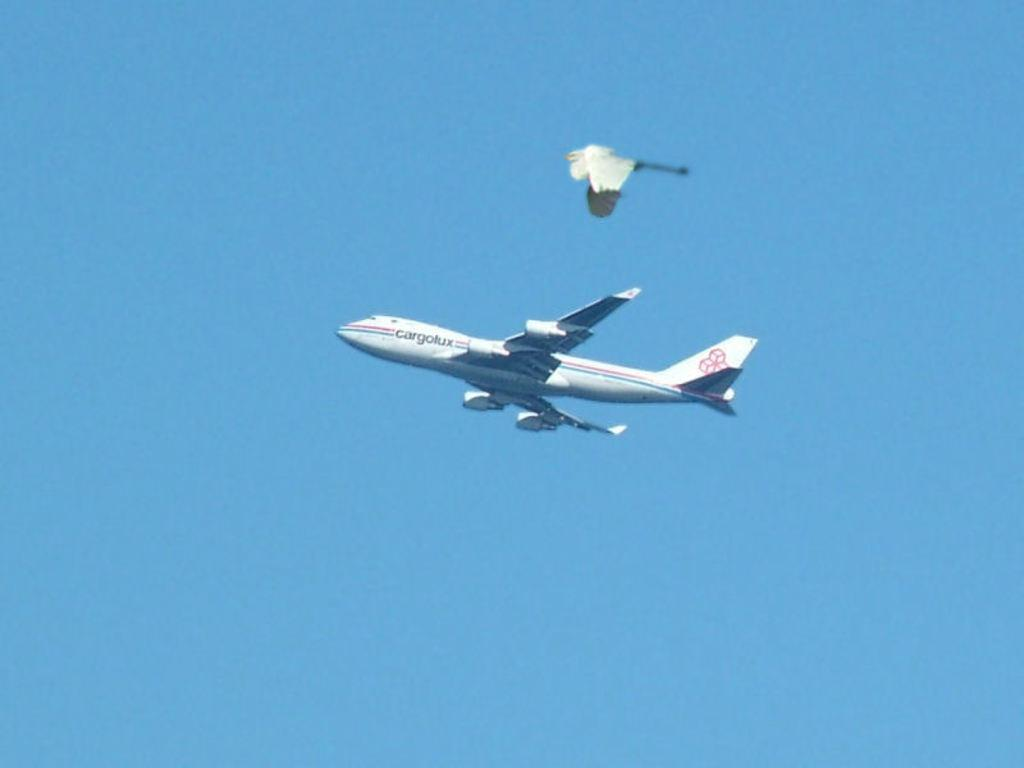What is the main subject of the image? The main subject of the image is an aircraft flying in the air. Can you describe any other objects or subjects in the image? Yes, there appears to be a bird flying in the air above the aircraft. What type of quince can be seen in the image? There is no quince present in the image; it features an aircraft and a bird flying in the air. 